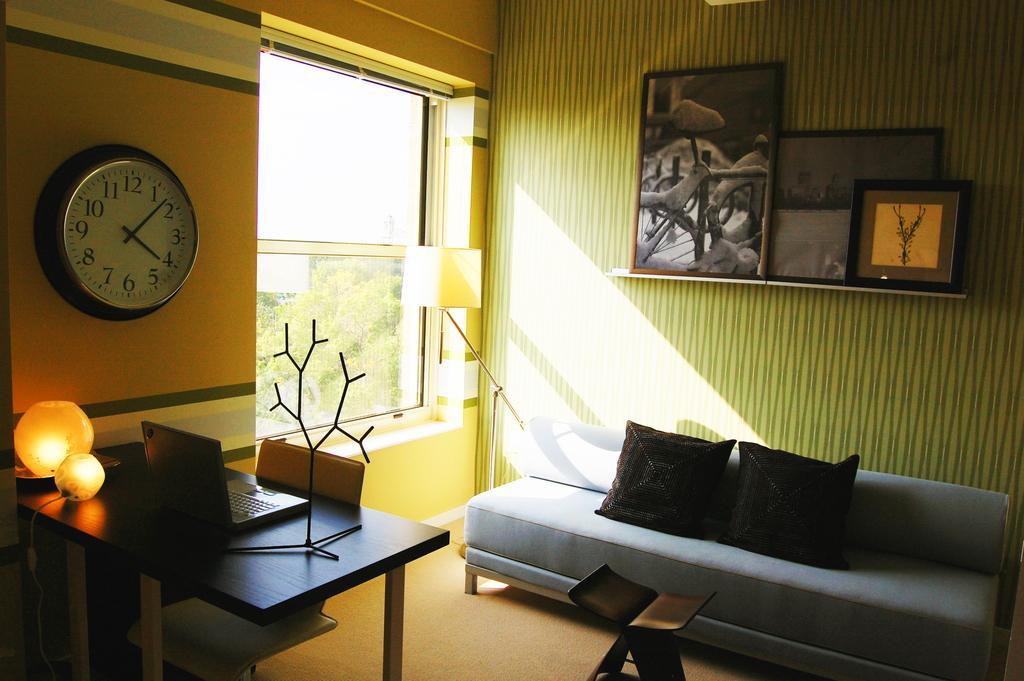How would you summarize this image in a sentence or two? This image consist of a room. To the right, there is a sofa in blue color on which there are two black pillows. To the left, there is a table on which a laptop and lights are kept. In the background, there is a wall and window. And there are frames and a wall clock fixed on the wall. 